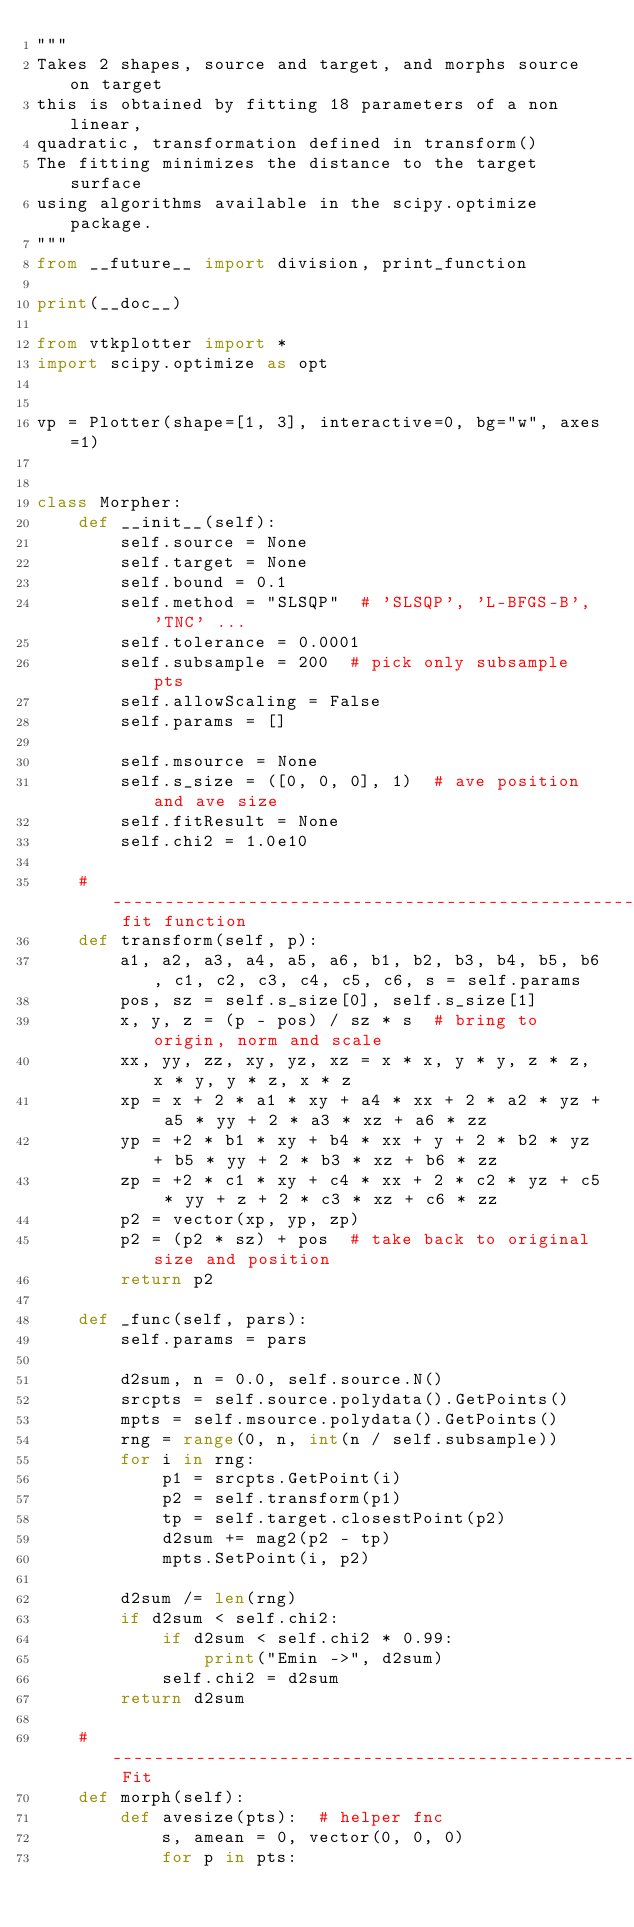Convert code to text. <code><loc_0><loc_0><loc_500><loc_500><_Python_>"""
Takes 2 shapes, source and target, and morphs source on target
this is obtained by fitting 18 parameters of a non linear,
quadratic, transformation defined in transform()
The fitting minimizes the distance to the target surface
using algorithms available in the scipy.optimize package.
"""
from __future__ import division, print_function

print(__doc__)

from vtkplotter import *
import scipy.optimize as opt


vp = Plotter(shape=[1, 3], interactive=0, bg="w", axes=1)


class Morpher:
    def __init__(self):
        self.source = None
        self.target = None
        self.bound = 0.1
        self.method = "SLSQP"  # 'SLSQP', 'L-BFGS-B', 'TNC' ...
        self.tolerance = 0.0001
        self.subsample = 200  # pick only subsample pts
        self.allowScaling = False
        self.params = []

        self.msource = None
        self.s_size = ([0, 0, 0], 1)  # ave position and ave size
        self.fitResult = None
        self.chi2 = 1.0e10

    # -------------------------------------------------------- fit function
    def transform(self, p):
        a1, a2, a3, a4, a5, a6, b1, b2, b3, b4, b5, b6, c1, c2, c3, c4, c5, c6, s = self.params
        pos, sz = self.s_size[0], self.s_size[1]
        x, y, z = (p - pos) / sz * s  # bring to origin, norm and scale
        xx, yy, zz, xy, yz, xz = x * x, y * y, z * z, x * y, y * z, x * z
        xp = x + 2 * a1 * xy + a4 * xx + 2 * a2 * yz + a5 * yy + 2 * a3 * xz + a6 * zz
        yp = +2 * b1 * xy + b4 * xx + y + 2 * b2 * yz + b5 * yy + 2 * b3 * xz + b6 * zz
        zp = +2 * c1 * xy + c4 * xx + 2 * c2 * yz + c5 * yy + z + 2 * c3 * xz + c6 * zz
        p2 = vector(xp, yp, zp)
        p2 = (p2 * sz) + pos  # take back to original size and position
        return p2

    def _func(self, pars):
        self.params = pars

        d2sum, n = 0.0, self.source.N()
        srcpts = self.source.polydata().GetPoints()
        mpts = self.msource.polydata().GetPoints()
        rng = range(0, n, int(n / self.subsample))
        for i in rng:
            p1 = srcpts.GetPoint(i)
            p2 = self.transform(p1)
            tp = self.target.closestPoint(p2)
            d2sum += mag2(p2 - tp)
            mpts.SetPoint(i, p2)

        d2sum /= len(rng)
        if d2sum < self.chi2:
            if d2sum < self.chi2 * 0.99:
                print("Emin ->", d2sum)
            self.chi2 = d2sum
        return d2sum

    # ------------------------------------------------------- Fit
    def morph(self):
        def avesize(pts):  # helper fnc
            s, amean = 0, vector(0, 0, 0)
            for p in pts:</code> 